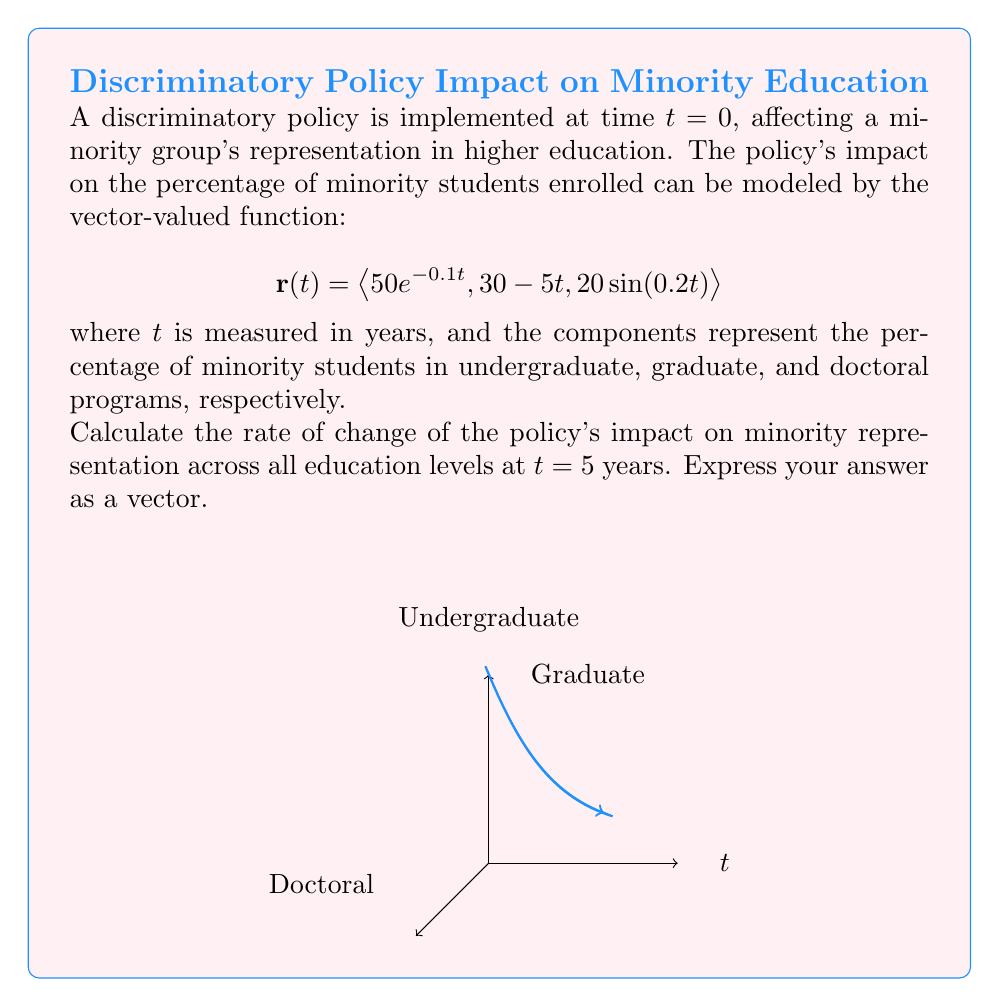Can you answer this question? To solve this problem, we need to follow these steps:

1) The vector-valued function $\mathbf{r}(t)$ represents the trajectory of the policy's impact over time. To find the rate of change, we need to calculate its derivative $\mathbf{r}'(t)$.

2) Let's differentiate each component of $\mathbf{r}(t)$:

   For the first component: $\frac{d}{dt}(50e^{-0.1t}) = -5e^{-0.1t}$
   
   For the second component: $\frac{d}{dt}(30 - 5t) = -5$
   
   For the third component: $\frac{d}{dt}(20\sin(0.2t)) = 4\cos(0.2t)$

3) Therefore, $\mathbf{r}'(t) = \langle -5e^{-0.1t}, -5, 4\cos(0.2t) \rangle$

4) We need to evaluate this at $t=5$:

   $\mathbf{r}'(5) = \langle -5e^{-0.5}, -5, 4\cos(1) \rangle$

5) Calculating the values:
   
   $e^{-0.5} \approx 0.6065$
   $\cos(1) \approx 0.5403$

6) Substituting these values:

   $\mathbf{r}'(5) \approx \langle -3.0325, -5, 2.1612 \rangle$

This vector represents the rate of change of the policy's impact on minority representation in undergraduate, graduate, and doctoral programs, respectively, after 5 years.
Answer: $\mathbf{r}'(5) \approx \langle -3.0325, -5, 2.1612 \rangle$ 